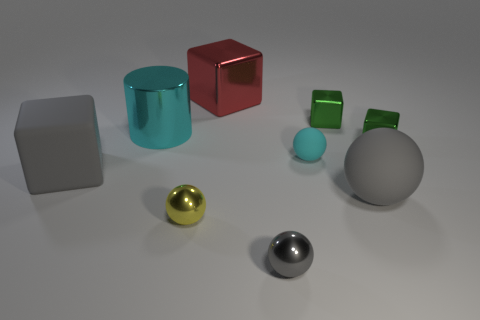Subtract 1 cubes. How many cubes are left? 3 Add 1 red spheres. How many objects exist? 10 Subtract all cubes. How many objects are left? 5 Subtract all yellow shiny balls. Subtract all tiny cyan matte things. How many objects are left? 7 Add 1 large metal cylinders. How many large metal cylinders are left? 2 Add 4 large red cubes. How many large red cubes exist? 5 Subtract 1 red blocks. How many objects are left? 8 